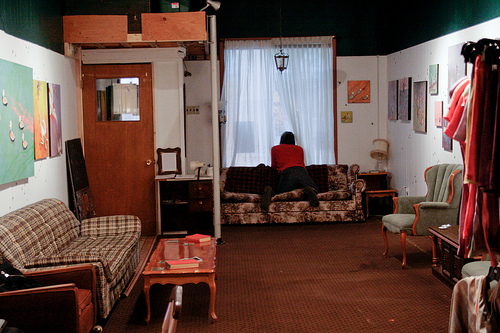<image>
Can you confirm if the art is above the couch? Yes. The art is positioned above the couch in the vertical space, higher up in the scene. 